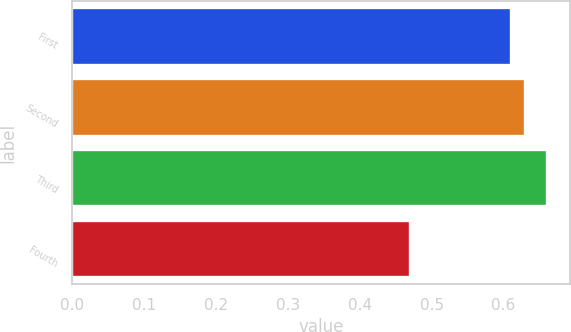Convert chart. <chart><loc_0><loc_0><loc_500><loc_500><bar_chart><fcel>First<fcel>Second<fcel>Third<fcel>Fourth<nl><fcel>0.61<fcel>0.63<fcel>0.66<fcel>0.47<nl></chart> 